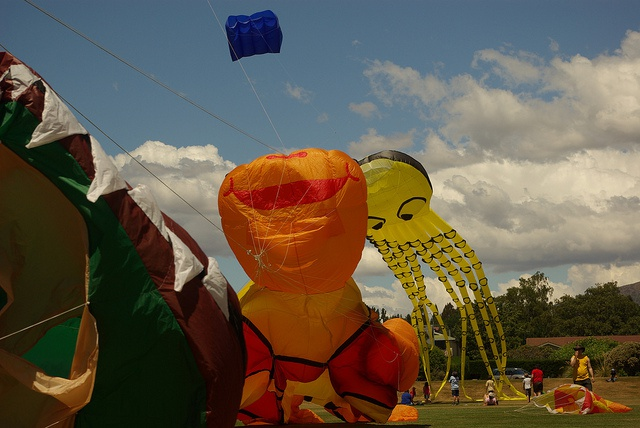Describe the objects in this image and their specific colors. I can see kite in blue, black, maroon, and tan tones, kite in blue, maroon, brown, and black tones, kite in blue, black, and olive tones, kite in blue, navy, and gray tones, and kite in blue, maroon, and olive tones in this image. 